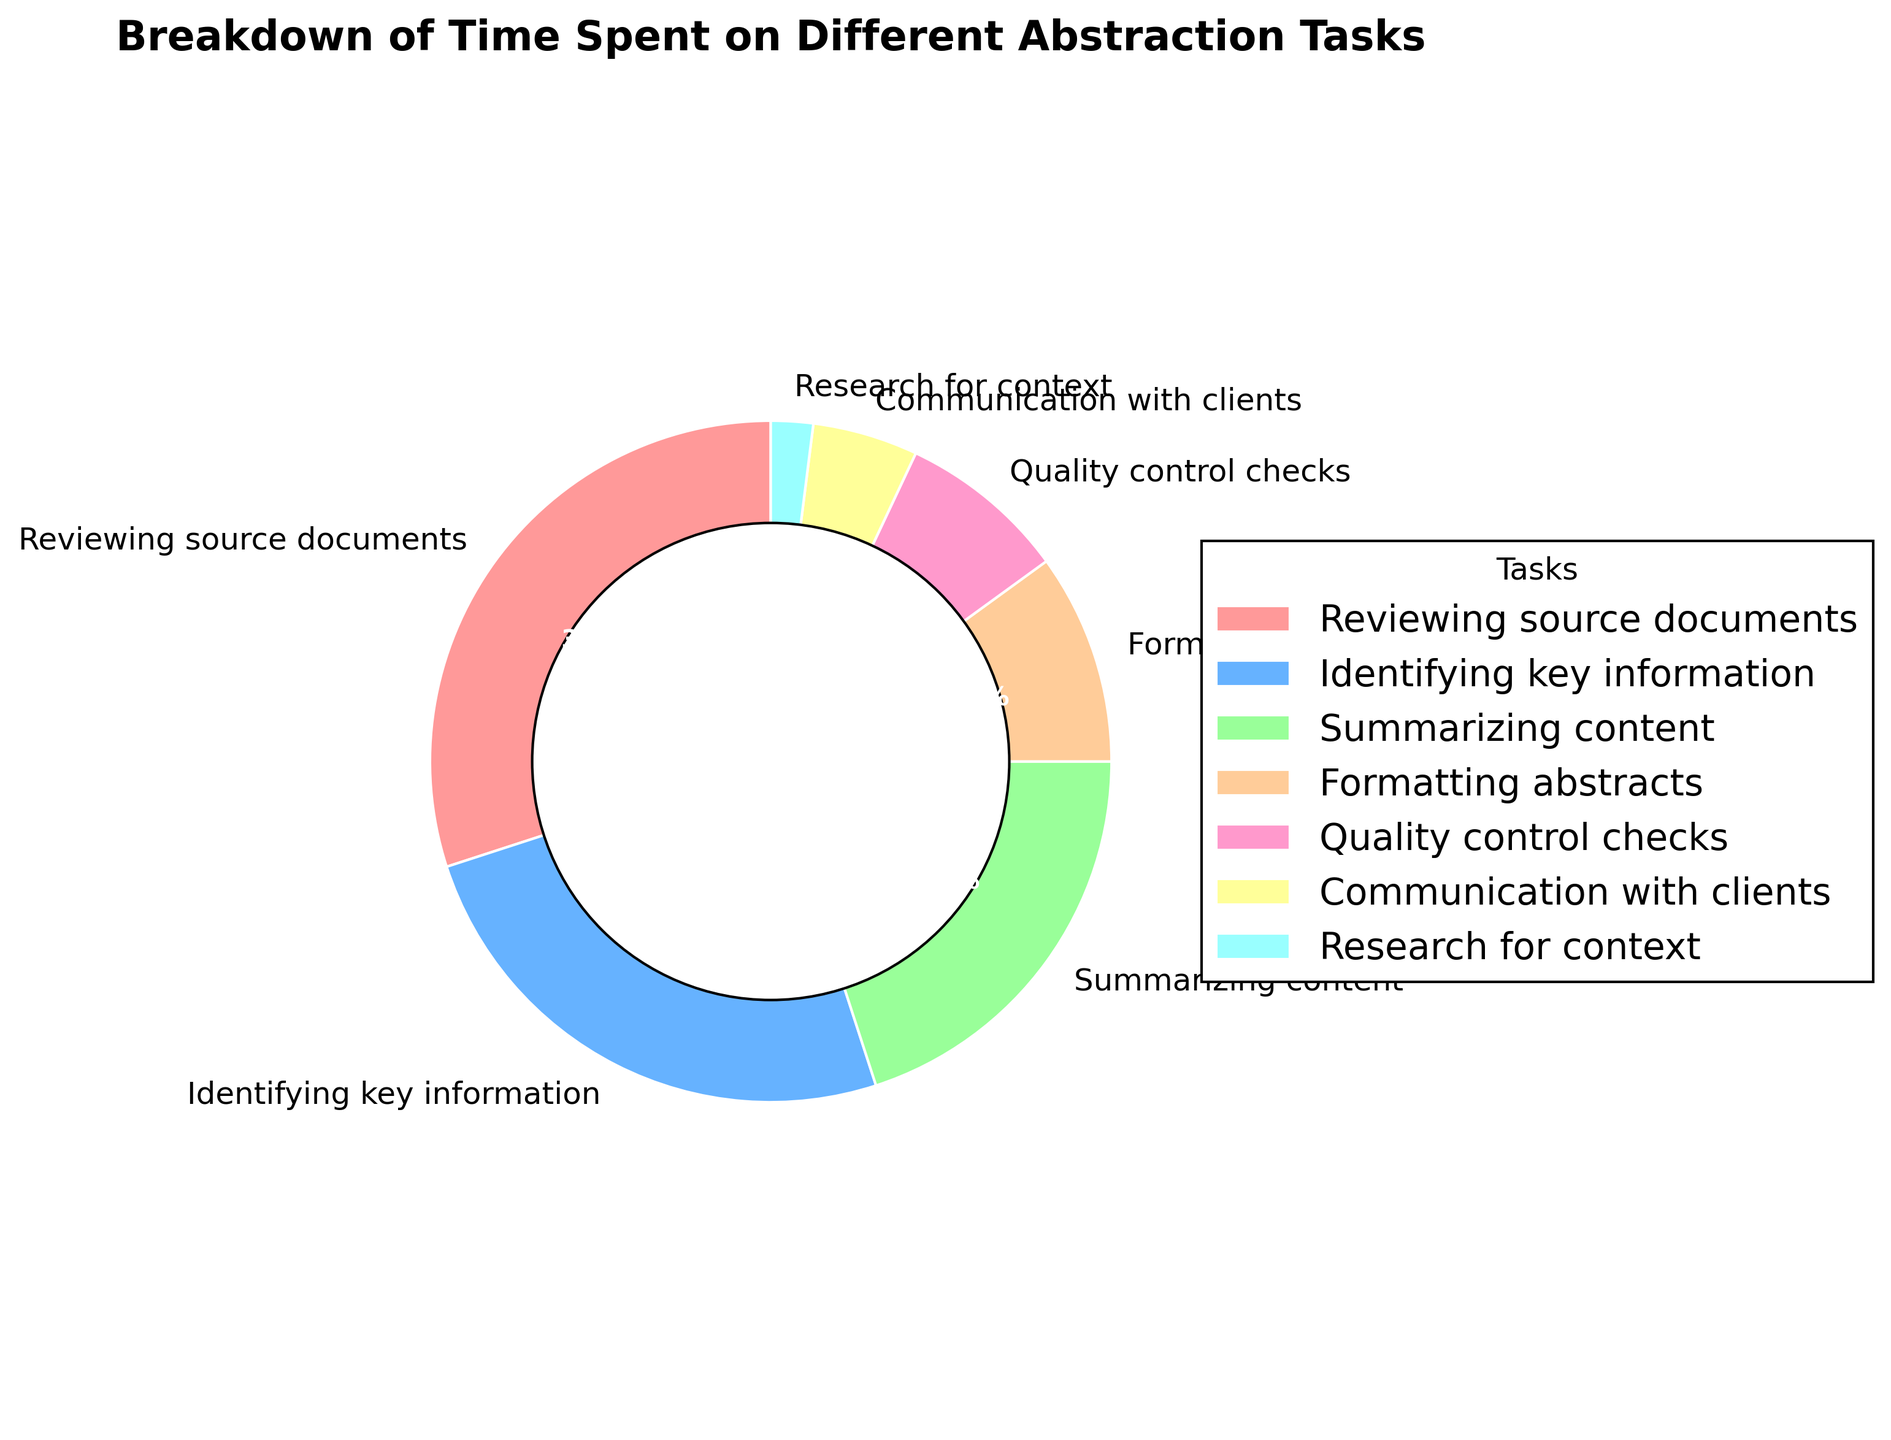What task takes up the largest percentage of time? The figure shows that "Reviewing source documents" is the largest segment in the pie chart at 30%.
Answer: Reviewing source documents What is the combined percentage of time spent on "Identifying key information" and "Summarizing content"? Add the percentages for "Identifying key information" (25%) and "Summarizing content" (20%). So, 25% + 20% = 45%.
Answer: 45% Which task takes up less time: "Communication with clients" or "Research for context"? The figure shows "Communication with clients" at 5%, whereas "Research for context" is at 2%. Since 2% is less than 5%, "Research for context" takes up less time.
Answer: Research for context Are "Quality control checks" and "Formatting abstracts" together more than "Identifying key information"? Add the percentages for "Quality control checks" (8%) and "Formatting abstracts" (10%). Compare the sum (18%) with "Identifying key information" (25%). Since 18% is less than 25%, the combined time is not more.
Answer: No Which segment is represented by the smallest part of the pie chart? The smallest segment in the pie chart is "Research for context" with 2%.
Answer: Research for context What fraction of the pie chart is occupied by tasks other than "Reviewing source documents" and "Identifying key information"? Calculate the total percentage of all tasks and subtract the percentages for "Reviewing source documents" (30%) and "Identifying key information" (25%). The total is 100%, so 100% - 30% - 25% = 45%.
Answer: 45% Which task is represented by the yellow color in the chart? Identify the task corresponding to the yellow segment of the pie chart. The task listed next to the yellow segment is "Quality control checks".
Answer: Quality control checks How much more percentage is spent on "Summarizing content" compared to "Formatting abstracts"? Compare the percentages for "Summarizing content" (20%) and "Formatting abstracts" (10%). The difference is 20% - 10% = 10%.
Answer: 10% If you group "Quality control checks", "Communication with clients", and "Research for context" together, what percentage of the time is spent on these activities? Add the percentages for "Quality control checks" (8%), "Communication with clients" (5%), and "Research for context" (2%). The total is 8% + 5% + 2% = 15%.
Answer: 15% What is the ratio of time spent on "Reviewing source documents" to "Quality control checks"? Compare the percentages for "Reviewing source documents" (30%) and "Quality control checks" (8%). The ratio is 30:8 or simplified as 15:4.
Answer: 15:4 